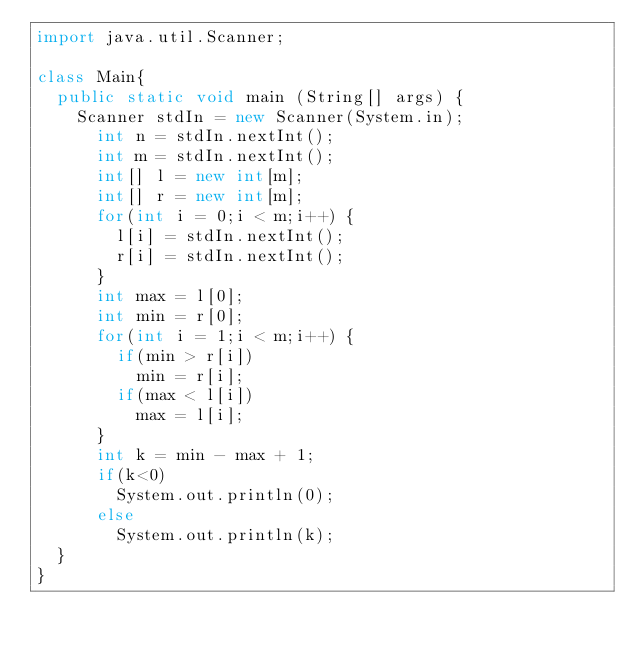<code> <loc_0><loc_0><loc_500><loc_500><_Java_>import java.util.Scanner;

class Main{
	public static void main (String[] args) {
		Scanner stdIn = new Scanner(System.in);
	    int n = stdIn.nextInt();
	    int m = stdIn.nextInt();
	    int[] l = new int[m];
	    int[] r = new int[m];
	    for(int i = 0;i < m;i++) {
	    	l[i] = stdIn.nextInt();
	    	r[i] = stdIn.nextInt();
	    }
	    int max = l[0];
	    int min = r[0];
	    for(int i = 1;i < m;i++) {
	    	if(min > r[i])
	    		min = r[i];
	    	if(max < l[i])
	    		max = l[i];
	    }
	    int k = min - max + 1;
	    if(k<0)
	    	System.out.println(0);
	    else
	    	System.out.println(k);
	}
}</code> 